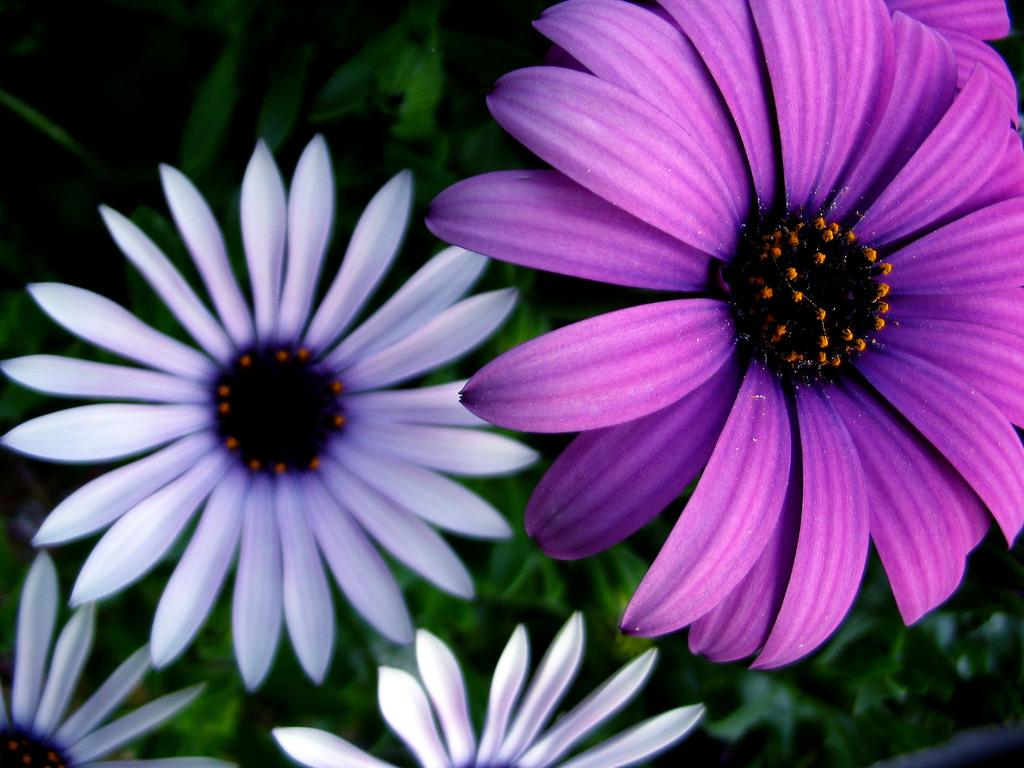What type of flora is present in the image? There are flowers in the image. What colors can be seen on the flowers? The flowers are in white and purple colors. What can be seen in the background of the image? There are plants or trees in the background of the image. How is the background of the image depicted? The background of the image is blurred. What type of mint is used to flavor the flowers in the image? There is no mint or flavoring mentioned in the image; it features flowers in white and purple colors. What season is depicted in the image? The image does not depict a specific season; it only shows flowers and a blurred background. 